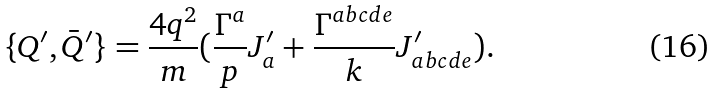Convert formula to latex. <formula><loc_0><loc_0><loc_500><loc_500>\{ Q ^ { \prime } , \bar { Q } ^ { \prime } \} = \frac { 4 q ^ { 2 } } { m } ( \frac { \Gamma ^ { a } } { p } J _ { a } ^ { \prime } + \frac { \Gamma ^ { a b c d e } } { k } J _ { a b c d e } ^ { \prime } ) .</formula> 